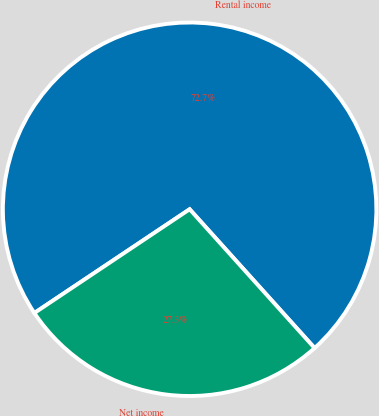<chart> <loc_0><loc_0><loc_500><loc_500><pie_chart><fcel>Rental income<fcel>Net income<nl><fcel>72.71%<fcel>27.29%<nl></chart> 